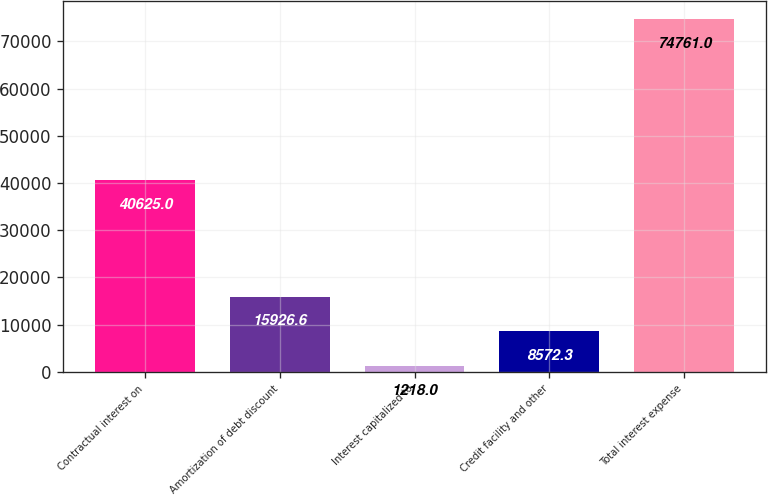Convert chart. <chart><loc_0><loc_0><loc_500><loc_500><bar_chart><fcel>Contractual interest on<fcel>Amortization of debt discount<fcel>Interest capitalized to<fcel>Credit facility and other<fcel>Total interest expense<nl><fcel>40625<fcel>15926.6<fcel>1218<fcel>8572.3<fcel>74761<nl></chart> 